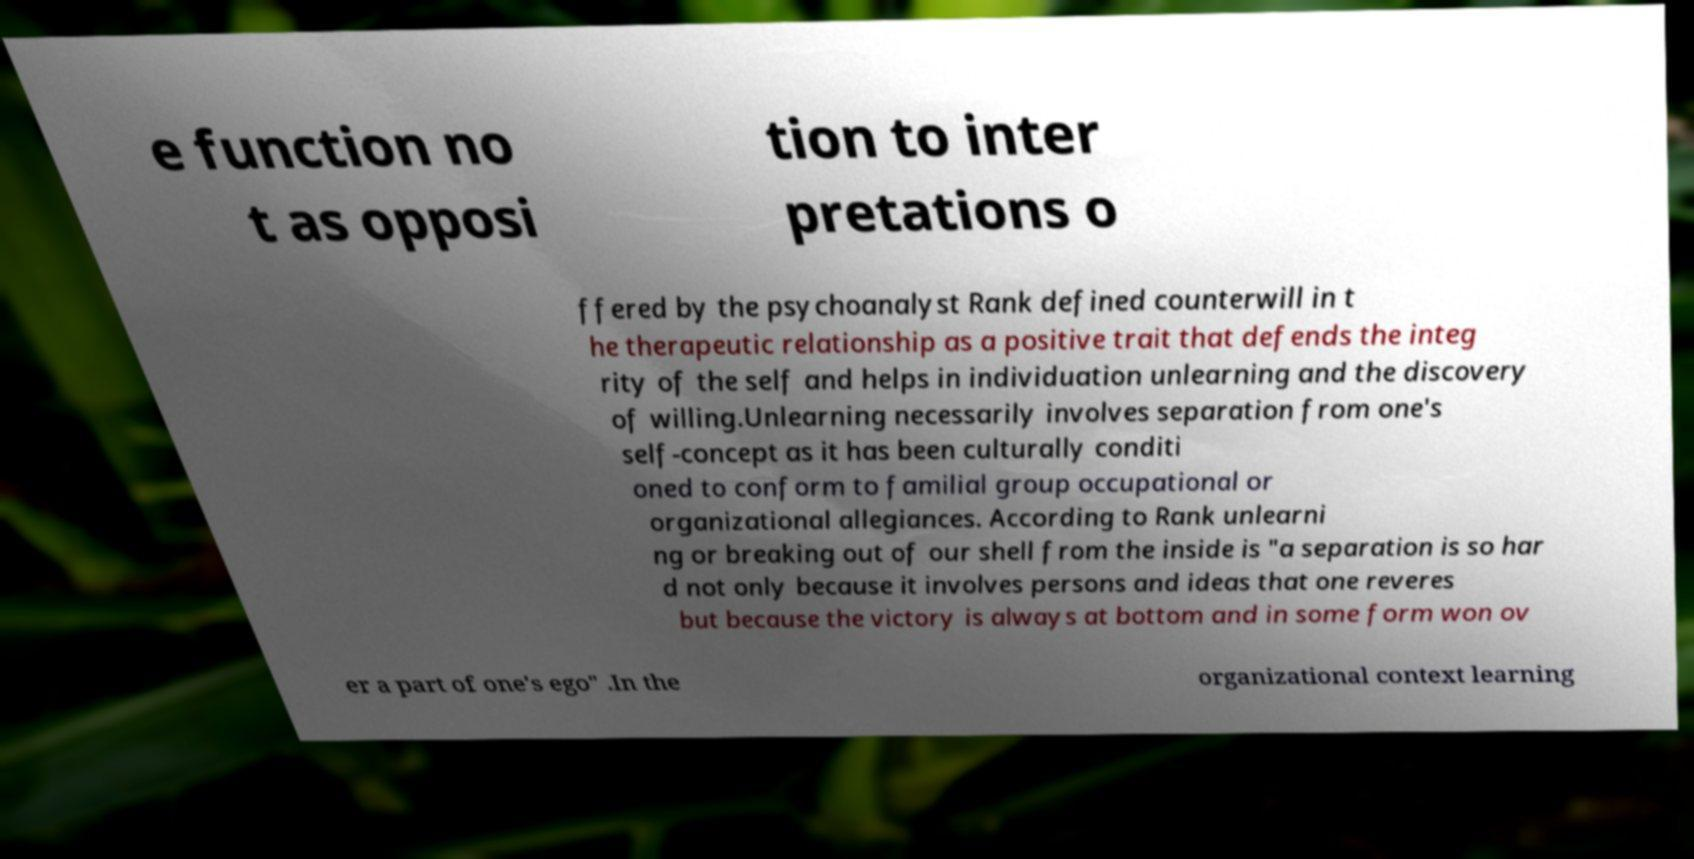For documentation purposes, I need the text within this image transcribed. Could you provide that? e function no t as opposi tion to inter pretations o ffered by the psychoanalyst Rank defined counterwill in t he therapeutic relationship as a positive trait that defends the integ rity of the self and helps in individuation unlearning and the discovery of willing.Unlearning necessarily involves separation from one's self-concept as it has been culturally conditi oned to conform to familial group occupational or organizational allegiances. According to Rank unlearni ng or breaking out of our shell from the inside is "a separation is so har d not only because it involves persons and ideas that one reveres but because the victory is always at bottom and in some form won ov er a part of one's ego" .In the organizational context learning 